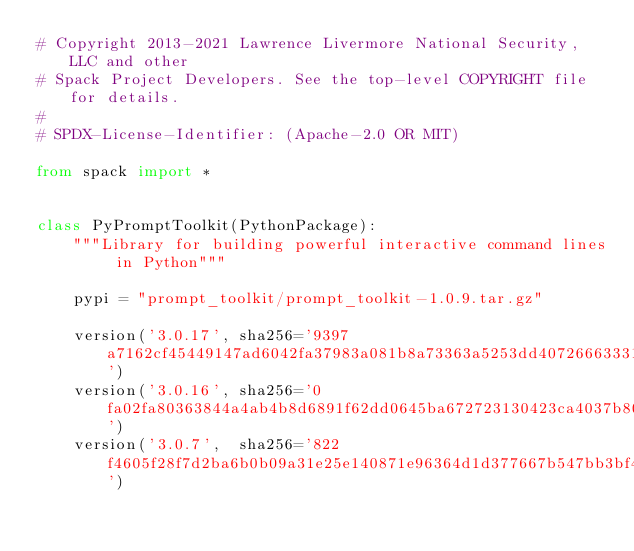<code> <loc_0><loc_0><loc_500><loc_500><_Python_># Copyright 2013-2021 Lawrence Livermore National Security, LLC and other
# Spack Project Developers. See the top-level COPYRIGHT file for details.
#
# SPDX-License-Identifier: (Apache-2.0 OR MIT)

from spack import *


class PyPromptToolkit(PythonPackage):
    """Library for building powerful interactive command lines in Python"""

    pypi = "prompt_toolkit/prompt_toolkit-1.0.9.tar.gz"

    version('3.0.17', sha256='9397a7162cf45449147ad6042fa37983a081b8a73363a5253dd4072666333137')
    version('3.0.16', sha256='0fa02fa80363844a4ab4b8d6891f62dd0645ba672723130423ca4037b80c1974')
    version('3.0.7',  sha256='822f4605f28f7d2ba6b0b09a31e25e140871e96364d1d377667b547bb3bf4489')</code> 